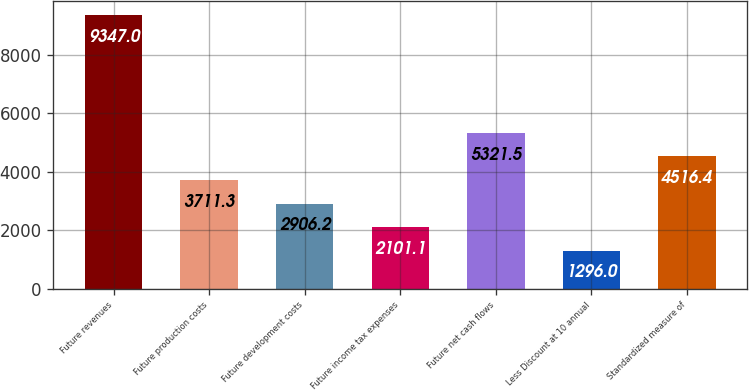<chart> <loc_0><loc_0><loc_500><loc_500><bar_chart><fcel>Future revenues<fcel>Future production costs<fcel>Future development costs<fcel>Future income tax expenses<fcel>Future net cash flows<fcel>Less Discount at 10 annual<fcel>Standardized measure of<nl><fcel>9347<fcel>3711.3<fcel>2906.2<fcel>2101.1<fcel>5321.5<fcel>1296<fcel>4516.4<nl></chart> 